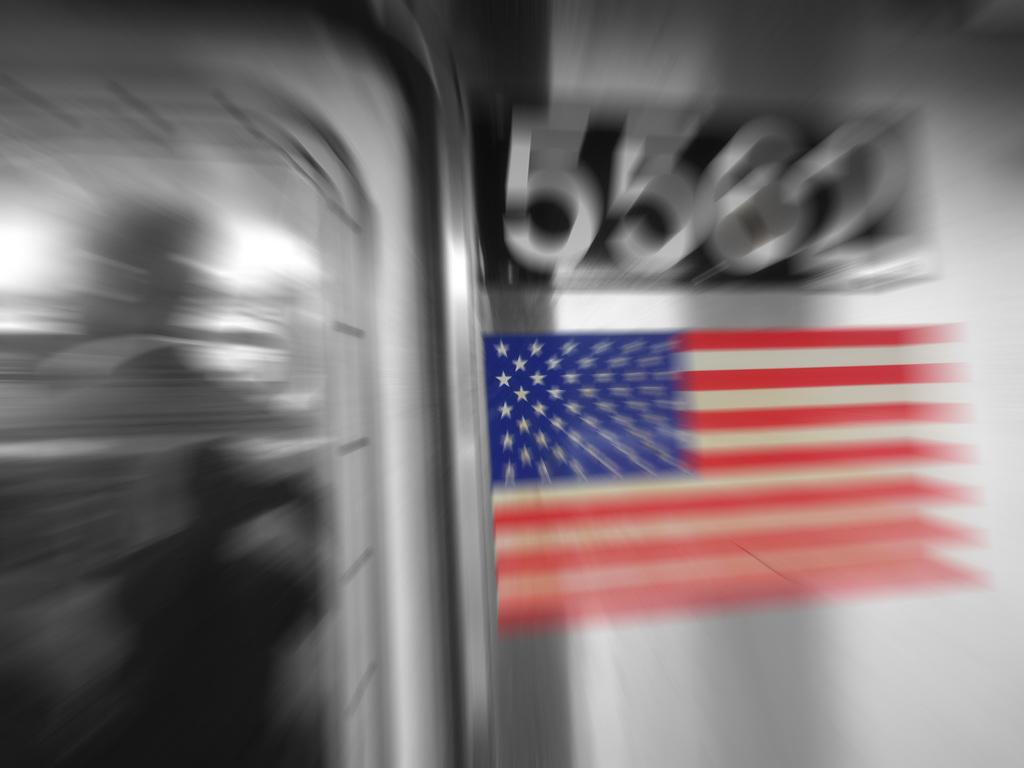What is located on the right side of the image? There is a flag on the right side of the image. What can be seen in addition to the flag? There are numbers visible in the image. What is on the left side of the image? There is a man standing on the left side of the image. How would you describe the overall clarity of the image? The image is blurred. Can you tell me how many pears are on the flag in the image? There are no pears present on the flag in the image. What type of dinosaurs can be seen walking in the background of the image? There are no dinosaurs present in the image; it only features a flag, numbers, and a man. 